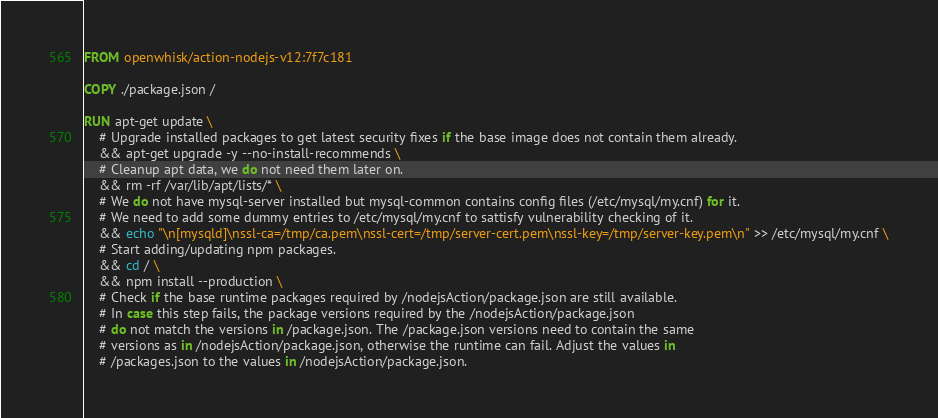<code> <loc_0><loc_0><loc_500><loc_500><_Dockerfile_>
FROM openwhisk/action-nodejs-v12:7f7c181

COPY ./package.json /

RUN apt-get update \
    # Upgrade installed packages to get latest security fixes if the base image does not contain them already.
    && apt-get upgrade -y --no-install-recommends \
    # Cleanup apt data, we do not need them later on.
    && rm -rf /var/lib/apt/lists/* \
    # We do not have mysql-server installed but mysql-common contains config files (/etc/mysql/my.cnf) for it.
    # We need to add some dummy entries to /etc/mysql/my.cnf to sattisfy vulnerability checking of it.
    && echo "\n[mysqld]\nssl-ca=/tmp/ca.pem\nssl-cert=/tmp/server-cert.pem\nssl-key=/tmp/server-key.pem\n" >> /etc/mysql/my.cnf \
    # Start adding/updating npm packages.
    && cd / \
    && npm install --production \
    # Check if the base runtime packages required by /nodejsAction/package.json are still available.
    # In case this step fails, the package versions required by the /nodejsAction/package.json
    # do not match the versions in /package.json. The /package.json versions need to contain the same
    # versions as in /nodejsAction/package.json, otherwise the runtime can fail. Adjust the values in
    # /packages.json to the values in /nodejsAction/package.json.</code> 